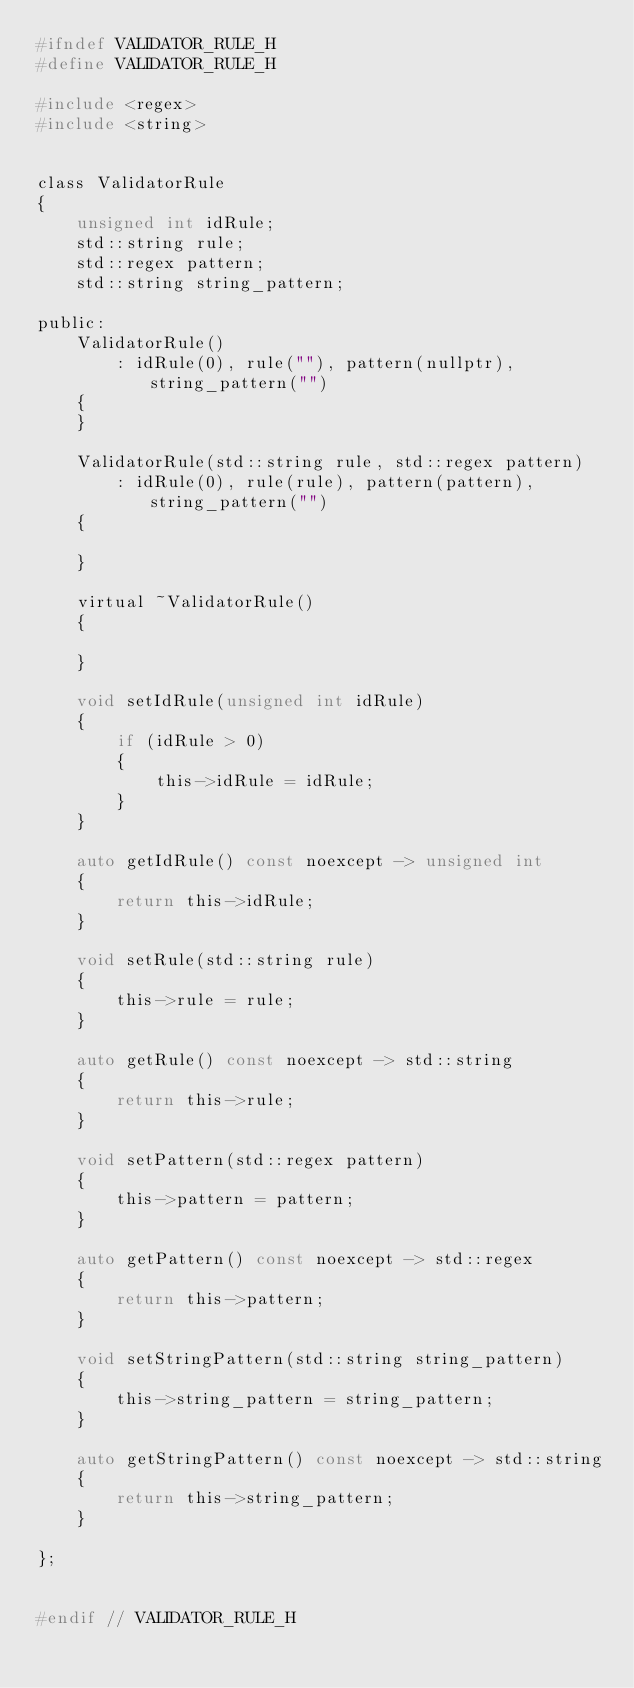<code> <loc_0><loc_0><loc_500><loc_500><_C_>#ifndef VALIDATOR_RULE_H
#define VALIDATOR_RULE_H

#include <regex>
#include <string>


class ValidatorRule
{
    unsigned int idRule;
    std::string rule;
    std::regex pattern;
    std::string string_pattern;

public:
    ValidatorRule()
        : idRule(0), rule(""), pattern(nullptr), string_pattern("")
    {
    }

    ValidatorRule(std::string rule, std::regex pattern)
        : idRule(0), rule(rule), pattern(pattern), string_pattern("")
    {

    }

    virtual ~ValidatorRule()
    {

    }

    void setIdRule(unsigned int idRule)
    {
        if (idRule > 0)
        {
            this->idRule = idRule;
        }
    }

    auto getIdRule() const noexcept -> unsigned int
    {
        return this->idRule;
    }

    void setRule(std::string rule)
    {
        this->rule = rule;
    }

    auto getRule() const noexcept -> std::string
    {
        return this->rule;
    }

    void setPattern(std::regex pattern)
    {
        this->pattern = pattern;
    }

    auto getPattern() const noexcept -> std::regex
    {
        return this->pattern;
    }

    void setStringPattern(std::string string_pattern)
    {
        this->string_pattern = string_pattern;
    }

    auto getStringPattern() const noexcept -> std::string
    {
        return this->string_pattern;
    }

};


#endif // VALIDATOR_RULE_H
</code> 